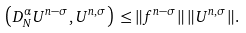Convert formula to latex. <formula><loc_0><loc_0><loc_500><loc_500>\left ( { D } ^ { \alpha } _ { N } U ^ { n - \sigma } , U ^ { n , \sigma } \right ) \, \leq & \, \| f ^ { n - \sigma } \| \, \| U ^ { n , \sigma } \| .</formula> 